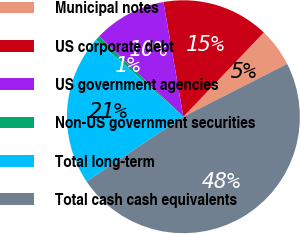<chart> <loc_0><loc_0><loc_500><loc_500><pie_chart><fcel>Municipal notes<fcel>US corporate debt<fcel>US government agencies<fcel>Non-US government securities<fcel>Total long-term<fcel>Total cash cash equivalents<nl><fcel>5.38%<fcel>14.87%<fcel>10.13%<fcel>0.63%<fcel>20.88%<fcel>48.1%<nl></chart> 